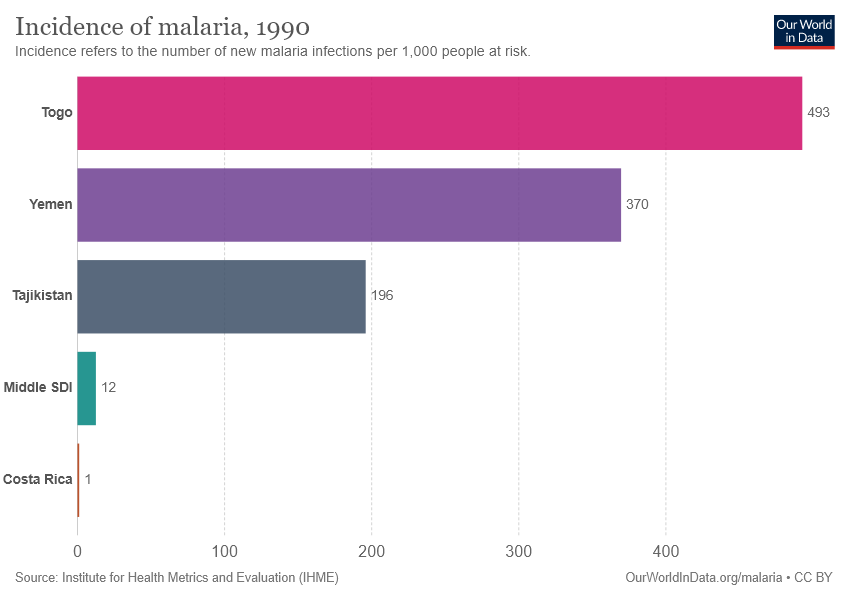List a handful of essential elements in this visual. The incidence of malaria in Yemen was 370 per 100,000 population in 2019. The median in the incidence of malaria among the 5 countries is 214.4. 